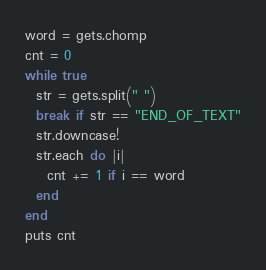Convert code to text. <code><loc_0><loc_0><loc_500><loc_500><_Ruby_>word = gets.chomp
cnt = 0
while true
  str = gets.split(" ")
  break if str == "END_OF_TEXT"
  str.downcase!
  str.each do |i|
    cnt += 1 if i == word
  end
end
puts cnt</code> 